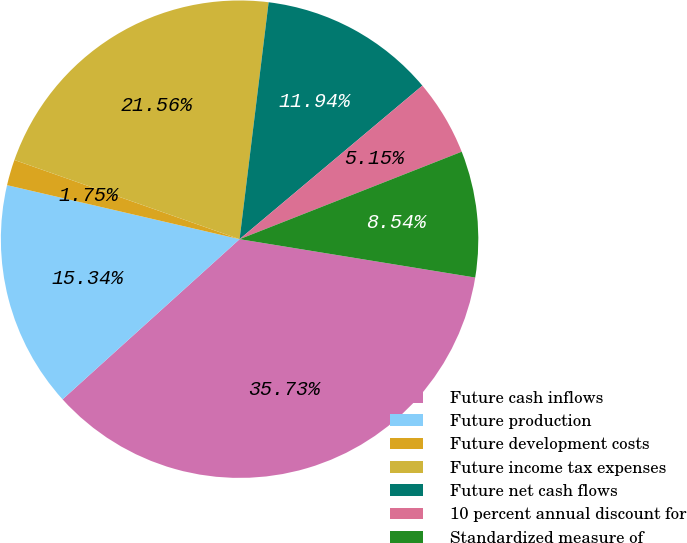<chart> <loc_0><loc_0><loc_500><loc_500><pie_chart><fcel>Future cash inflows<fcel>Future production<fcel>Future development costs<fcel>Future income tax expenses<fcel>Future net cash flows<fcel>10 percent annual discount for<fcel>Standardized measure of<nl><fcel>35.73%<fcel>15.34%<fcel>1.75%<fcel>21.56%<fcel>11.94%<fcel>5.15%<fcel>8.54%<nl></chart> 